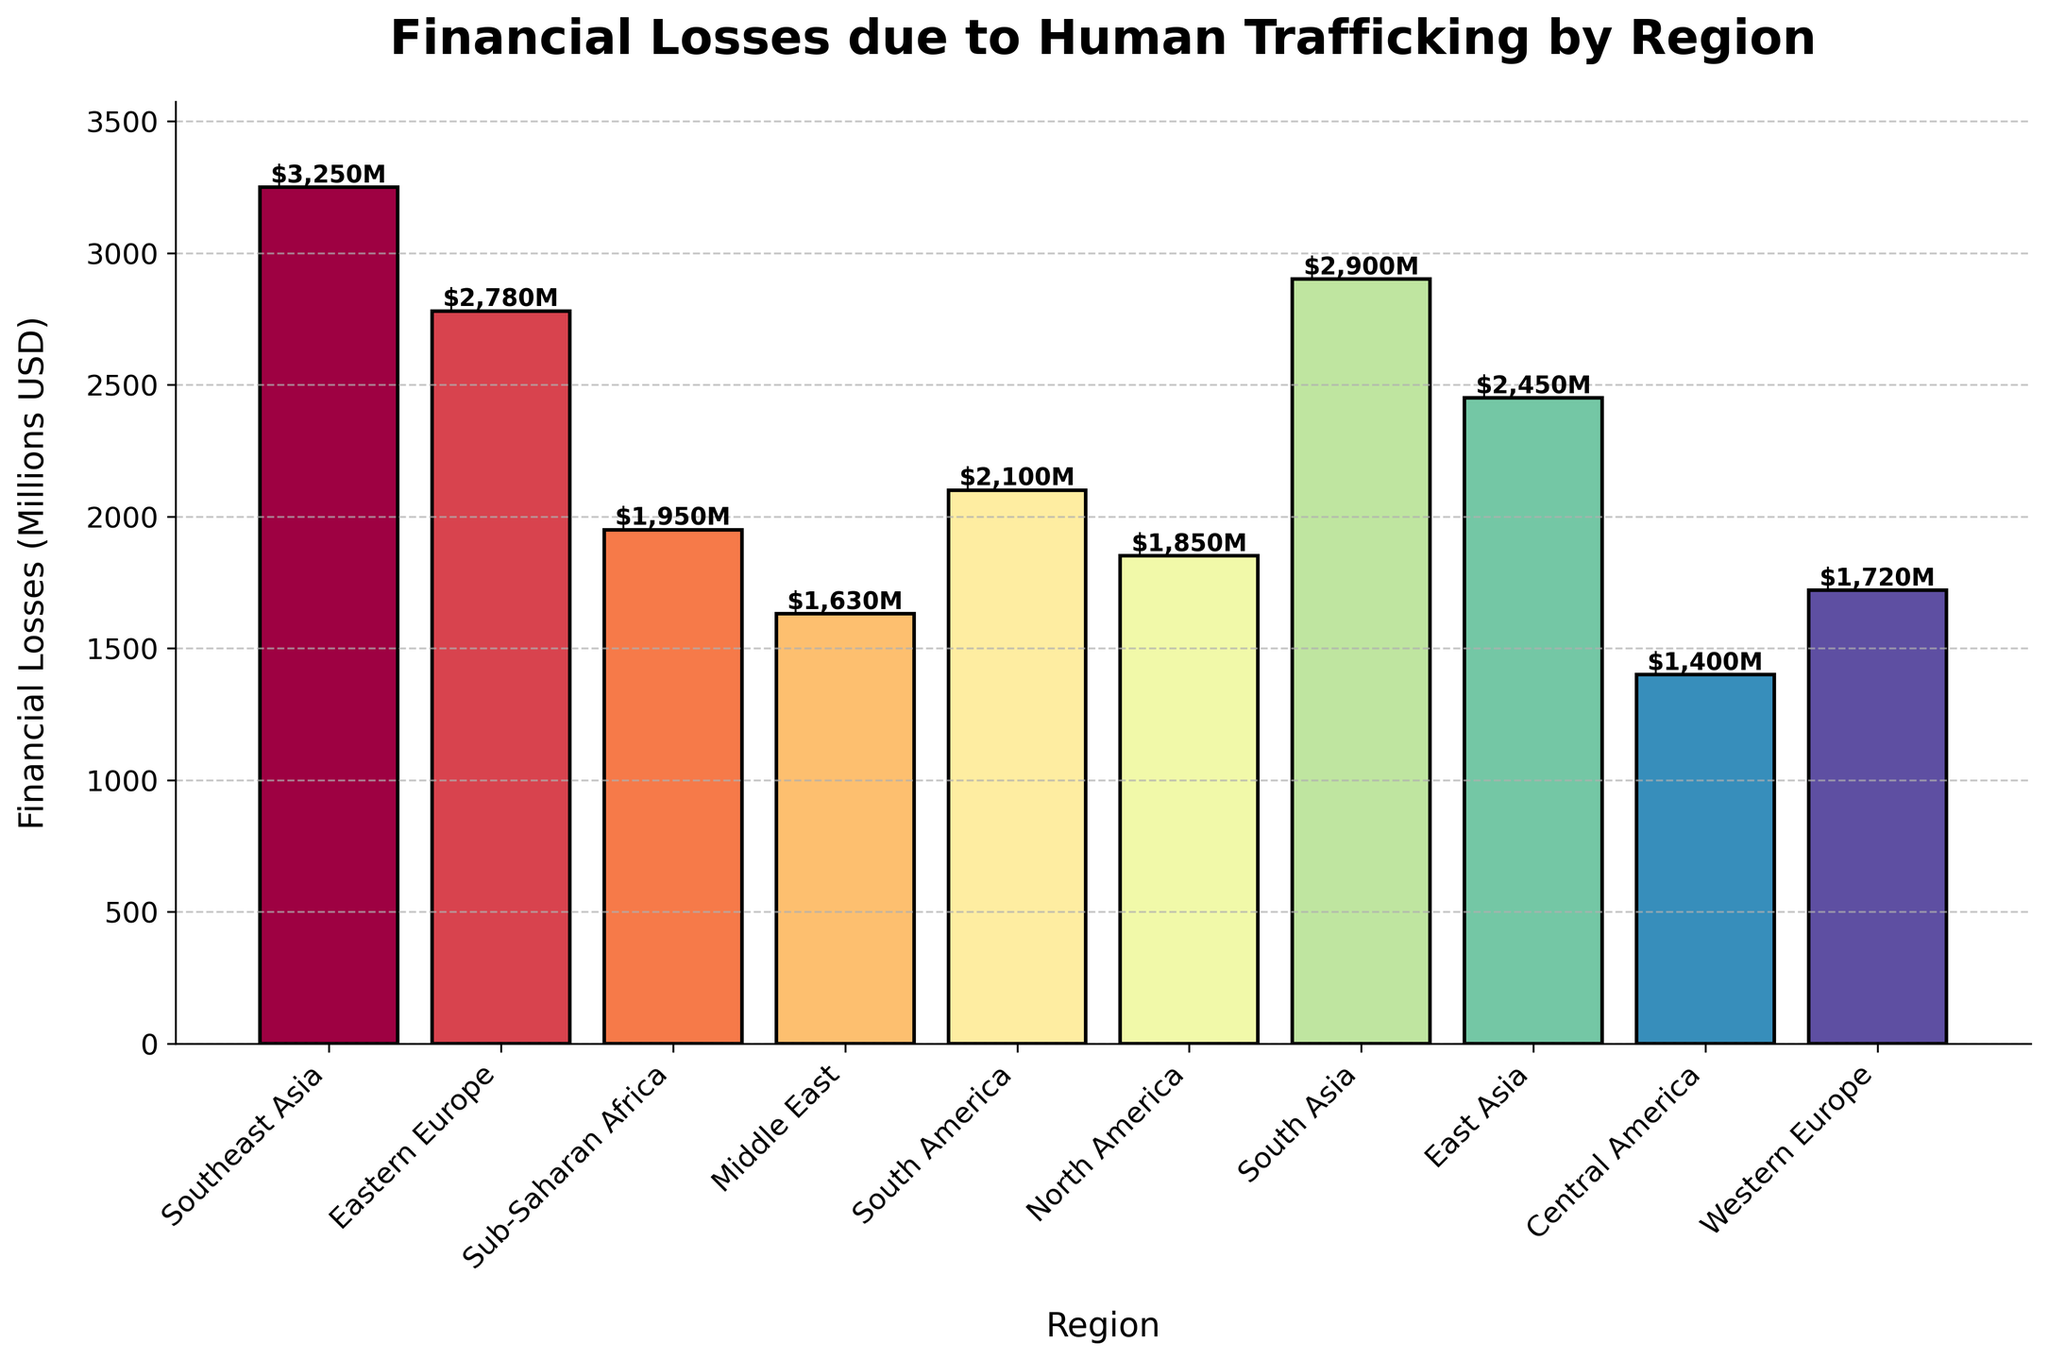Which region has the highest financial losses due to human trafficking? To find the region with the highest financial losses, look for the tallest bar in the chart. The highest bar represents Southeast Asia with financial losses of $3,250 million.
Answer: Southeast Asia Which region has the lowest financial losses due to human trafficking? To determine the region with the lowest financial losses, identify the shortest bar in the chart. The shortest bar corresponds to Central America with financial losses of $1,400 million.
Answer: Central America How much more financial loss does Southeast Asia have compared to Central America? Subtract the financial losses of Central America from those of Southeast Asia: $3,250 million - $1,400 million = $1,850 million.
Answer: $1,850 million What is the total financial loss of regions in Asia (Southeast Asia, South Asia, and East Asia)? Sum the financial losses for Southeast Asia ($3,250 million), South Asia ($2,900 million), and East Asia ($2,450 million): $3,250 million + $2,900 million + $2,450 million = $8,600 million.
Answer: $8,600 million Which region has higher financial losses due to human trafficking, North America or South America? Compare the height of the bars for North America and South America. North America's bar represents $1,850 million, whereas South America's bar represents $2,100 million. Hence, South America has higher financial losses.
Answer: South America Arrange the regions with financial losses above $2,000 million in descending order. Identify regions with losses greater than $2,000 million: Southeast Asia ($3,250 million), South Asia ($2,900 million), Eastern Europe ($2,780 million), East Asia ($2,450 million), and South America ($2,100 million). Arrange them in descending order: Southeast Asia, South Asia, Eastern Europe, East Asia, South America.
Answer: Southeast Asia, South Asia, Eastern Europe, East Asia, South America What is the average financial loss due to human trafficking across all regions? To calculate the average, sum the financial losses of all regions and divide by the number of regions. The total is $32,480 million for 10 regions: $32,480 million ÷ 10 = $3,248 million.
Answer: $3,248 million How much more does Eastern Europe lose compared to North America? Subtract the financial losses of North America from those of Eastern Europe: $2,780 million - $1,850 million = $930 million.
Answer: $930 million Is Sub-Saharan Africa's financial loss more than Western Europe's? Compare the heights of the bars for Sub-Saharan Africa and Western Europe. Sub-Saharan Africa has financial losses of $1,950 million, while Western Europe has $1,720 million. Therefore, Sub-Saharan Africa's loss is more.
Answer: Yes 